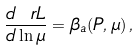<formula> <loc_0><loc_0><loc_500><loc_500>\frac { d \ r L } { d \ln \mu } = \beta _ { \L a } ( P , \mu ) \, ,</formula> 